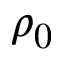Convert formula to latex. <formula><loc_0><loc_0><loc_500><loc_500>\rho _ { 0 }</formula> 